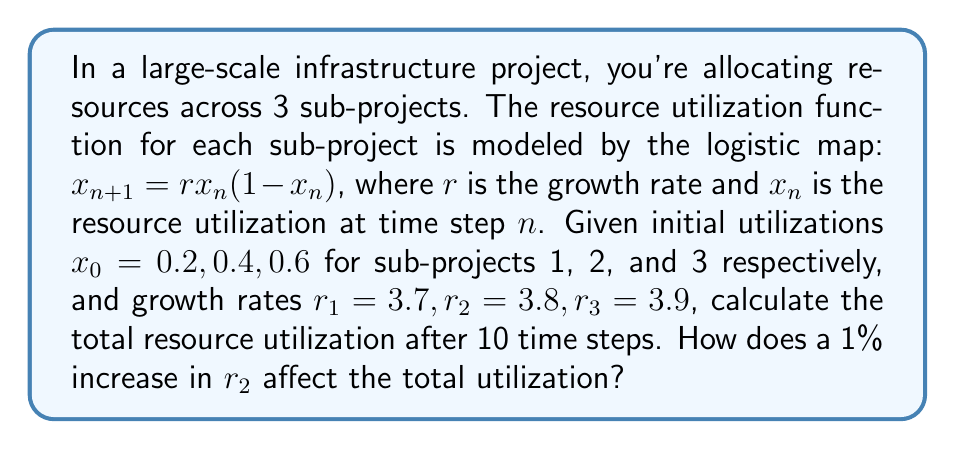Can you solve this math problem? To solve this problem, we'll follow these steps:

1) Calculate the resource utilization for each sub-project after 10 time steps using the logistic map equation.
2) Sum the utilizations to get the total.
3) Recalculate with a 1% increase in $r_2$ and compare the results.

Step 1: Calculate utilizations

For each sub-project, we'll use the logistic map equation iteratively:

$$x_{n+1} = rx_n(1-x_n)$$

Sub-project 1: $r_1 = 3.7, x_0 = 0.2$
Sub-project 2: $r_2 = 3.8, x_0 = 0.4$
Sub-project 3: $r_3 = 3.9, x_0 = 0.6$

Using a computer or calculator to iterate 10 times:

Sub-project 1: $x_{10} \approx 0.8602$
Sub-project 2: $x_{10} \approx 0.8261$
Sub-project 3: $x_{10} \approx 0.8175$

Step 2: Calculate total utilization

Total utilization = $0.8602 + 0.8261 + 0.8175 = 2.5038$

Step 3: Recalculate with 1% increase in $r_2$

New $r_2 = 3.8 * 1.01 = 3.838$

Recalculating sub-project 2 with $r_2 = 3.838$:

$x_{10} \approx 0.8301$

New total utilization = $0.8602 + 0.8301 + 0.8175 = 2.5078$

The difference in total utilization:
$2.5078 - 2.5038 = 0.0040$

This represents a 0.16% increase in total utilization.
Answer: 0.0040 (0.16% increase) 